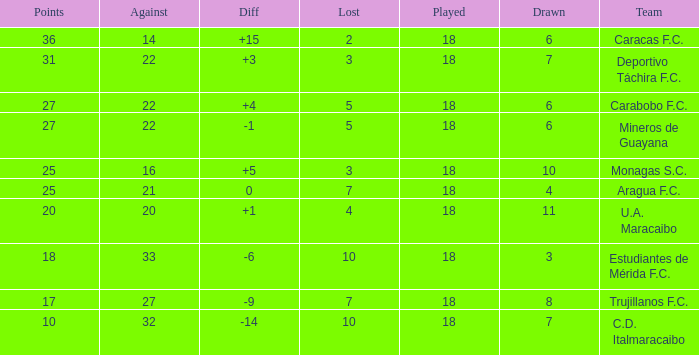What is the average against score of all teams with less than 7 losses, more than 6 draws, and 25 points? 16.0. 